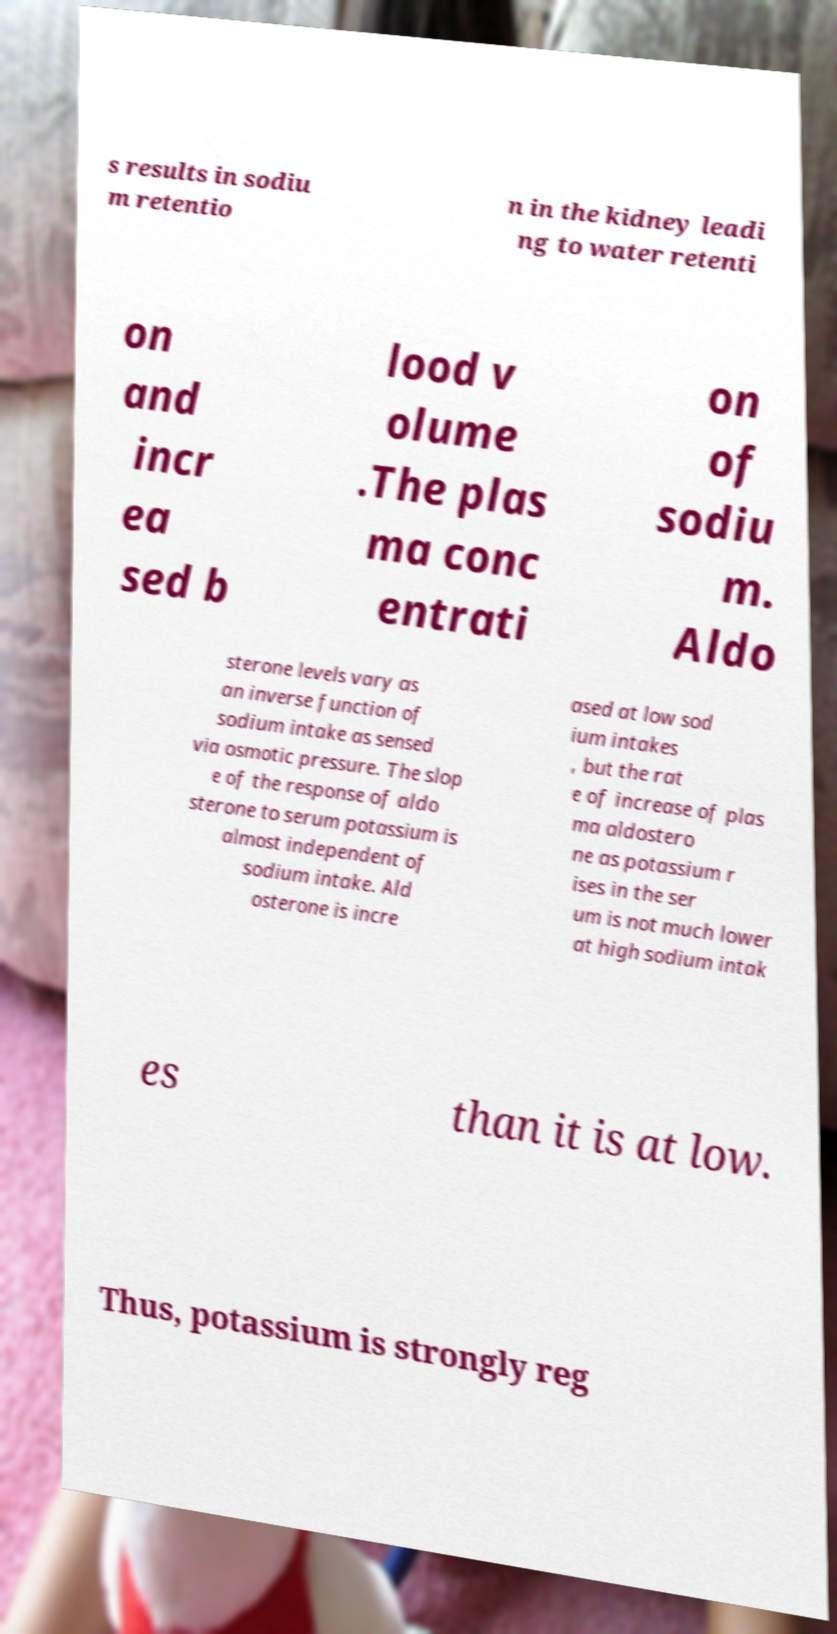Could you extract and type out the text from this image? s results in sodiu m retentio n in the kidney leadi ng to water retenti on and incr ea sed b lood v olume .The plas ma conc entrati on of sodiu m. Aldo sterone levels vary as an inverse function of sodium intake as sensed via osmotic pressure. The slop e of the response of aldo sterone to serum potassium is almost independent of sodium intake. Ald osterone is incre ased at low sod ium intakes , but the rat e of increase of plas ma aldostero ne as potassium r ises in the ser um is not much lower at high sodium intak es than it is at low. Thus, potassium is strongly reg 